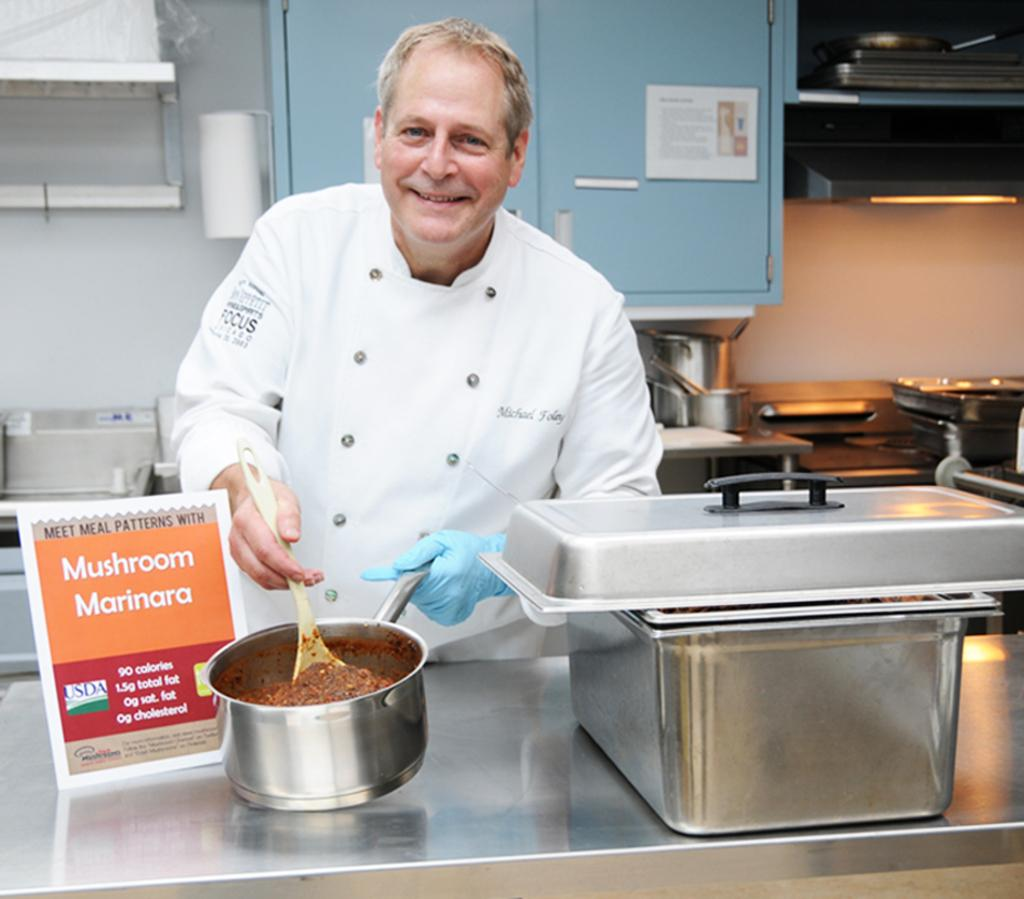<image>
Render a clear and concise summary of the photo. Chef Michael holds a pot with Mushroom Marinara in one hand and a cooking spoon in the other. 